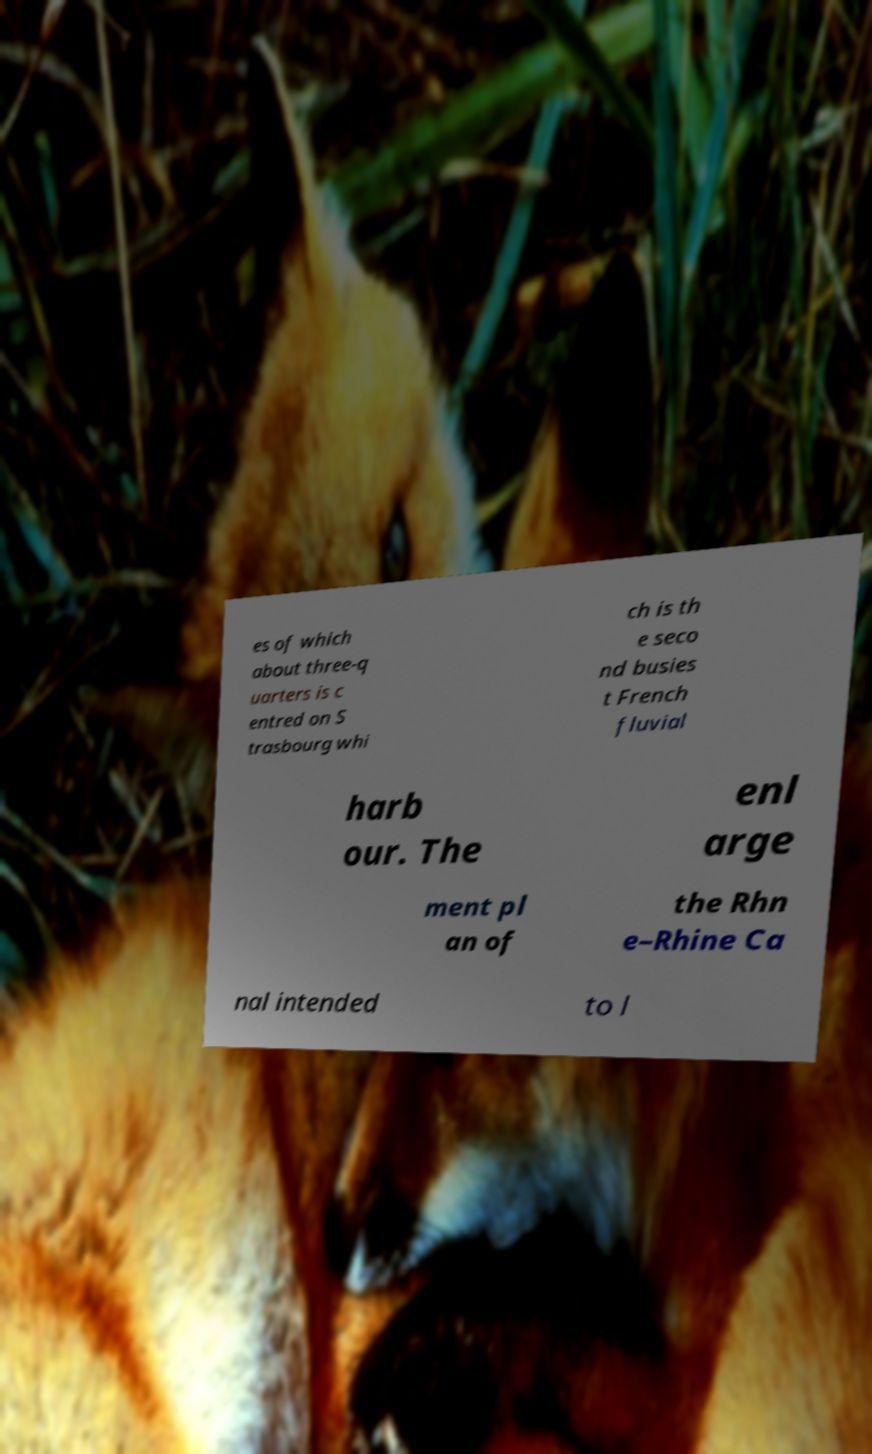Please identify and transcribe the text found in this image. es of which about three-q uarters is c entred on S trasbourg whi ch is th e seco nd busies t French fluvial harb our. The enl arge ment pl an of the Rhn e–Rhine Ca nal intended to l 